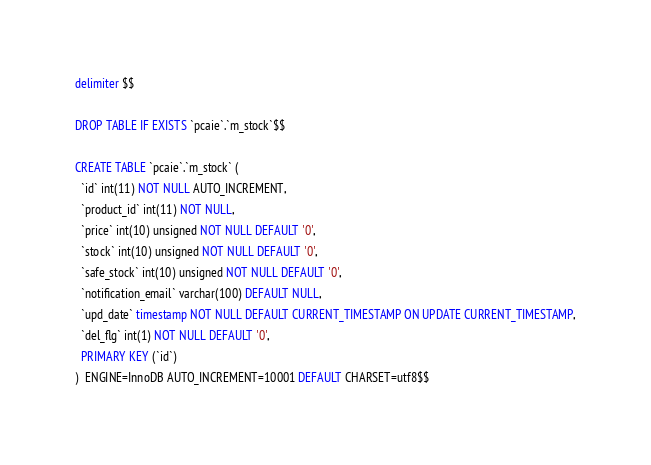<code> <loc_0><loc_0><loc_500><loc_500><_SQL_>delimiter $$

DROP TABLE IF EXISTS `pcaie`.`m_stock`$$

CREATE TABLE `pcaie`.`m_stock` (
  `id` int(11) NOT NULL AUTO_INCREMENT,
  `product_id` int(11) NOT NULL,
  `price` int(10) unsigned NOT NULL DEFAULT '0',
  `stock` int(10) unsigned NOT NULL DEFAULT '0',
  `safe_stock` int(10) unsigned NOT NULL DEFAULT '0',
  `notification_email` varchar(100) DEFAULT NULL,
  `upd_date` timestamp NOT NULL DEFAULT CURRENT_TIMESTAMP ON UPDATE CURRENT_TIMESTAMP,
  `del_flg` int(1) NOT NULL DEFAULT '0',
  PRIMARY KEY (`id`)
)  ENGINE=InnoDB AUTO_INCREMENT=10001 DEFAULT CHARSET=utf8$$</code> 